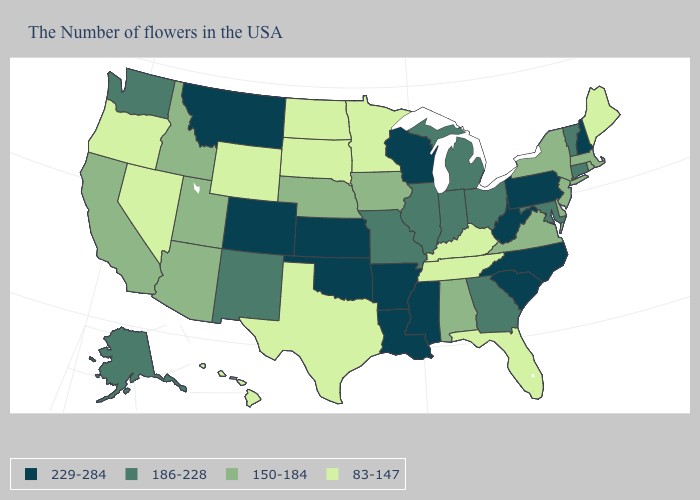Which states have the lowest value in the West?
Concise answer only. Wyoming, Nevada, Oregon, Hawaii. What is the lowest value in the West?
Answer briefly. 83-147. Name the states that have a value in the range 83-147?
Be succinct. Maine, Florida, Kentucky, Tennessee, Minnesota, Texas, South Dakota, North Dakota, Wyoming, Nevada, Oregon, Hawaii. What is the value of Illinois?
Give a very brief answer. 186-228. How many symbols are there in the legend?
Keep it brief. 4. What is the value of Missouri?
Give a very brief answer. 186-228. Name the states that have a value in the range 83-147?
Write a very short answer. Maine, Florida, Kentucky, Tennessee, Minnesota, Texas, South Dakota, North Dakota, Wyoming, Nevada, Oregon, Hawaii. What is the value of Arkansas?
Quick response, please. 229-284. Which states have the lowest value in the USA?
Give a very brief answer. Maine, Florida, Kentucky, Tennessee, Minnesota, Texas, South Dakota, North Dakota, Wyoming, Nevada, Oregon, Hawaii. What is the highest value in states that border New York?
Short answer required. 229-284. Name the states that have a value in the range 83-147?
Quick response, please. Maine, Florida, Kentucky, Tennessee, Minnesota, Texas, South Dakota, North Dakota, Wyoming, Nevada, Oregon, Hawaii. What is the value of Delaware?
Write a very short answer. 150-184. Is the legend a continuous bar?
Concise answer only. No. What is the highest value in the USA?
Answer briefly. 229-284. What is the value of New Hampshire?
Keep it brief. 229-284. 